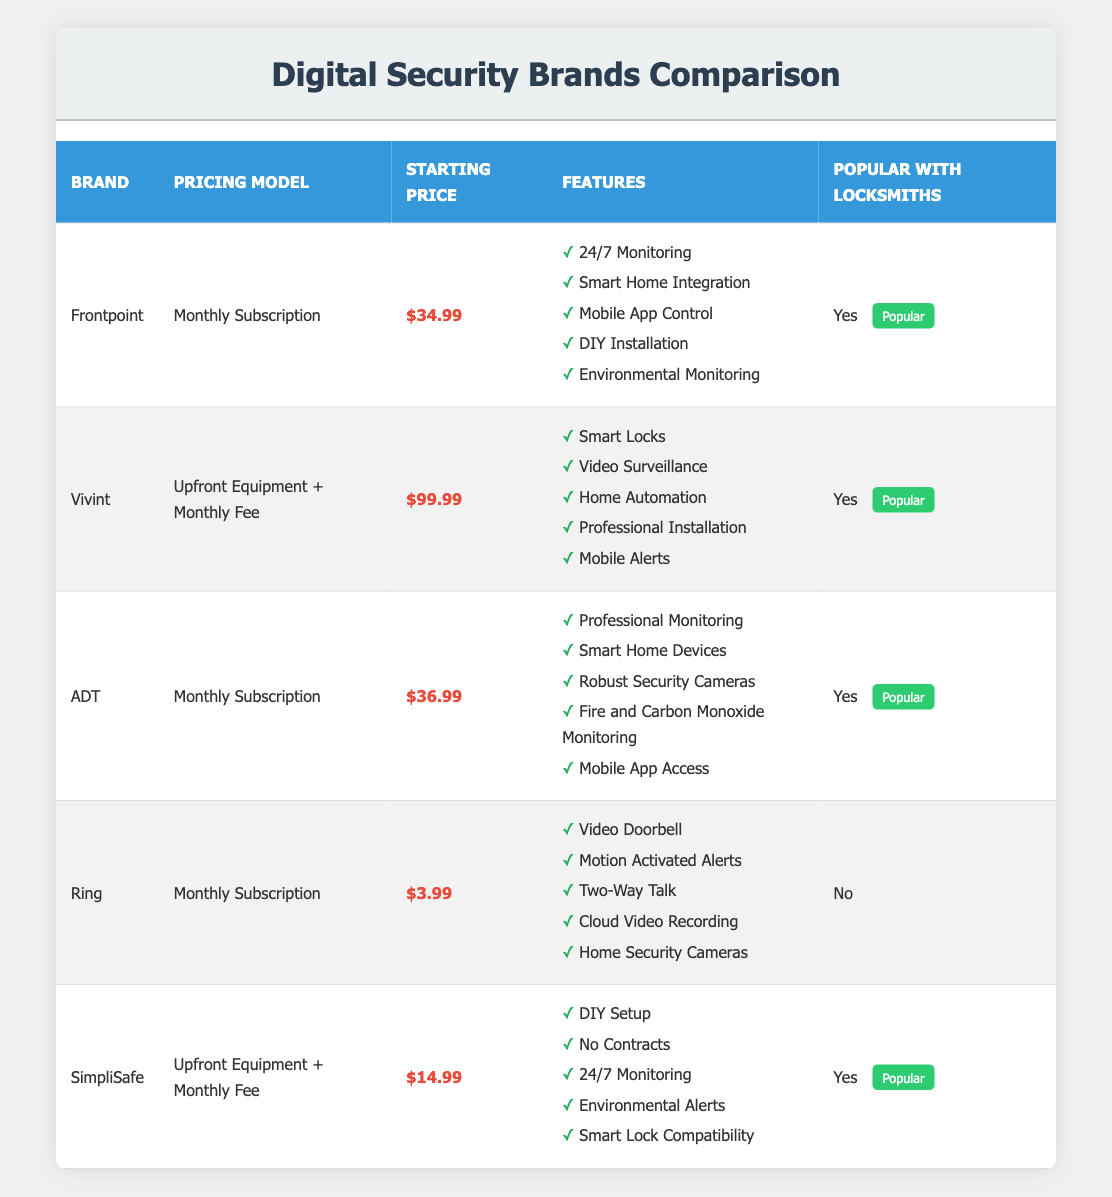What is the starting price of Vivint? The starting price of Vivint is explicitly mentioned in the table as $99.99.
Answer: $99.99 Which brand has the lowest starting price? By reviewing the starting prices in the table, Ring has the lowest price at $3.99 compared to others like Frontpoint at $34.99 and Vivint at $99.99.
Answer: Ring How many brands are popular with locksmiths? The table indicates that four out of the five brands (Frontpoint, Vivint, ADT, SimpliSafe) are marked as "Yes" for popularity with locksmiths.
Answer: 4 Is Smart Home Integration a feature of all brands? The table shows features for each brand; only Frontpoint includes Smart Home Integration, while it is not featured in Vivint, ADT, Ring, or SimpliSafe. Therefore, it is false that all brands have this feature.
Answer: No What is the average starting price of the brands popular with locksmiths? To calculate the average, we sum the starting prices of the four popular brands: 34.99 (Frontpoint) + 99.99 (Vivint) + 36.99 (ADT) + 14.99 (SimpliSafe) = 186.96. Dividing by 4 gives us 186.96 / 4 = 46.74.
Answer: 46.74 Which brand offers 24/7 Monitoring and is popular with locksmiths? Referring to the table, Frontpoint and SimpliSafe both offer 24/7 Monitoring and are marked as popular with locksmiths.
Answer: Frontpoint, SimpliSafe Is SimpliSafe more expensive than ADT? The starting price for SimpliSafe is $14.99, while ADT's starting price is $36.99. Since $14.99 is less than $36.99, the statement is false.
Answer: No Name one feature that all popular brands share. Upon reviewing the features of the four popular brands (Frontpoint, Vivint, ADT, SimpliSafe), 24/7 Monitoring is retained by Frontpoint and SimpliSafe, and Professional Monitoring is included by ADT, but no unique feature is common across all.
Answer: None How many unique features does Vivint have compared to other brands? Vivint has five distinct features listed, including Smart Locks and Professional Installation, which are not present in the other brands like Ring and SimpliSafe. Therefore, it is more comprehensive in comparison to brands with fewer features.
Answer: 5 